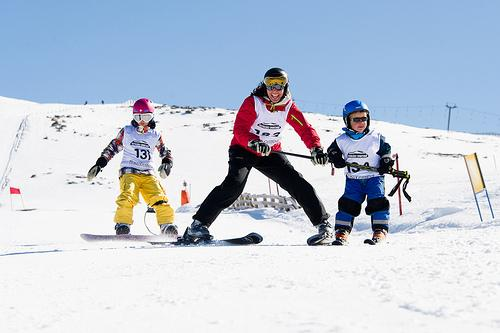Name three types of protective gear worn by the people in the image. Helmets, goggles, and gloves are the protective gear worn by the people in the image. Can you describe the electric post in the image? The electric post is black in colour and stands tall amidst the snow in the environment. What is the colour of the snow in the image? The snow is white in colour. Give a brief description of the environment where the people are skiing. The environment is surrounded by mountain covered with snow, with a blue sky above and several objects like a yellow sign and an electric post. Count the number of children wearing helmets in the image. There are three children wearing helmets, one pink, one blue, and one red. What is the colour of the pants worn by the skier on the left side of the image? The skier on the left side is wearing yellow pants. Explain the visual appearance of the jacket one person is wearing. The jacket is red in colour and its size covers the person's torso with a wide dimension. Describe the sky in the image. The sky is blue in colour and covers a large portion of the image. Identify any signs or markings in the image and describe their colours. There's a yellow sign to the right of the kid, and numerations on the chests of the skiers: 131, and unidentified numbers on a woman and a child. What are the three people in the image doing? Three people are skiing and wearing snowsuits with protective gear such as helmets and goggles. How would you feel if you were skiing in this mountain area? Excited and happy because of the beautiful snow and blue sky. Please assess the overall quality of this photo. The quality is good with clear visibility of objects and well-defined colors. Describe the scene shown in the image. Three people are skiing, wearing colorful snowsuits and helmets. They are surrounded by snow and a blue sky. There is a yellow sign and an electric post nearby. Describe the appearance of the child wearing a white and blue outfit. The child has a blue helmet, white goggles, blue and black pants, and is located at X:325 Y:91 Width:86 Height:86. Highlight the parts of the image covered with snow. X:243 Y:245 Width:25 Height:25, X:274 Y:240 Width:33 Height:33, X:85 Y:254 Width:270 Height:270 Who's holding the ski pole? A child at X:336 Y:100 Width:57 Height:57 is holding the ski pole. In what color pants is the child wearing yellow pants? Yellow, located at X:112 Y:171 Width:75 Height:75 Identify the relationships and interactions between objects in the image. Three people skiing together, a child holds ski pole, kids wearing gear, people near sign and electric post, snow on mountain. Identify the text on the numeration on the woman's chest. The text is "131" at X:131 Y:143 Width:27 Height:27. What number is written on the child's chest? There is no number written on the child's chest. What is the overall sentiment in the image? Joyful and exciting, with people skiing and lots of snow Enumerate any kids that are wearing helmets in the image. There is a child wearing a blue helmet, a child wearing a red helmet, and a child wearing a pink helmet. Locate any unusual objects or elements in the image. There is nothing unusual or out of place in this snowy mountain scene. Identify the skier in the image who's wearing a red jacket. The woman at X:227 Y:88 Width:105 Height:105 is wearing a red jacket. What color is the helmet worn by the child in the image? The child is wearing a blue helmet. Which number can be seen on the skier's chest in the image? The number 131 at X:131 Y:143 Width:27 Height:27 What object can you see at X:455 Y:130 Width:43 Height:43? A yellow sign Are there any children wearing gloves in the image? Yes, there is a child wearing gloves at X:154 Y:158 Width:22 Height:22. Which among these options is not in the image: snow, grass, sky? Grass 